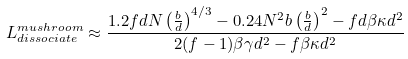Convert formula to latex. <formula><loc_0><loc_0><loc_500><loc_500>L ^ { m u s h r o o m } _ { d i s s o c i a t e } \approx \frac { 1 . 2 f d N \left ( \frac { b } { d } \right ) ^ { 4 / 3 } - 0 . 2 4 N ^ { 2 } b \left ( \frac { b } { d } \right ) ^ { 2 } - f d \beta \kappa d ^ { 2 } } { 2 ( f - 1 ) \beta \gamma d ^ { 2 } - f \beta \kappa d ^ { 2 } }</formula> 